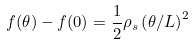Convert formula to latex. <formula><loc_0><loc_0><loc_500><loc_500>f ( \theta ) - f ( 0 ) = \frac { 1 } { 2 } \rho _ { s } \left ( { \theta } / { L } \right ) ^ { 2 }</formula> 